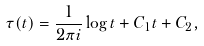Convert formula to latex. <formula><loc_0><loc_0><loc_500><loc_500>\tau ( t ) = \frac { 1 } { 2 \pi i } \log t + C _ { 1 } t + C _ { 2 } ,</formula> 